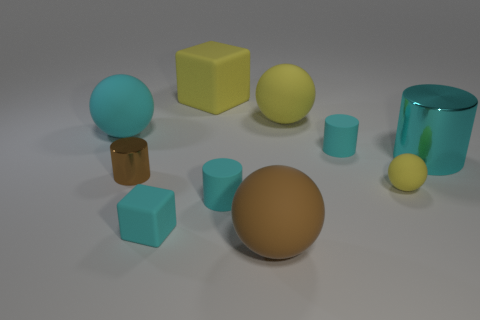Subtract all green balls. How many cyan cylinders are left? 3 Subtract all gray cylinders. Subtract all red spheres. How many cylinders are left? 4 Subtract all cubes. How many objects are left? 8 Add 7 big brown rubber spheres. How many big brown rubber spheres exist? 8 Subtract 3 cyan cylinders. How many objects are left? 7 Subtract all big purple metal cylinders. Subtract all cyan matte cylinders. How many objects are left? 8 Add 2 big yellow balls. How many big yellow balls are left? 3 